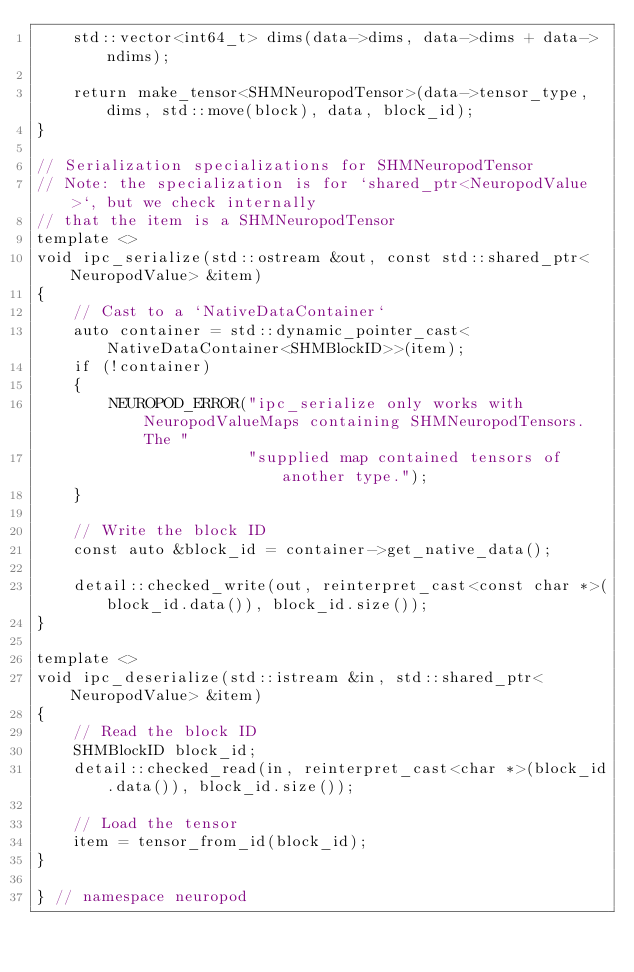Convert code to text. <code><loc_0><loc_0><loc_500><loc_500><_C++_>    std::vector<int64_t> dims(data->dims, data->dims + data->ndims);

    return make_tensor<SHMNeuropodTensor>(data->tensor_type, dims, std::move(block), data, block_id);
}

// Serialization specializations for SHMNeuropodTensor
// Note: the specialization is for `shared_ptr<NeuropodValue>`, but we check internally
// that the item is a SHMNeuropodTensor
template <>
void ipc_serialize(std::ostream &out, const std::shared_ptr<NeuropodValue> &item)
{
    // Cast to a `NativeDataContainer`
    auto container = std::dynamic_pointer_cast<NativeDataContainer<SHMBlockID>>(item);
    if (!container)
    {
        NEUROPOD_ERROR("ipc_serialize only works with NeuropodValueMaps containing SHMNeuropodTensors. The "
                       "supplied map contained tensors of another type.");
    }

    // Write the block ID
    const auto &block_id = container->get_native_data();

    detail::checked_write(out, reinterpret_cast<const char *>(block_id.data()), block_id.size());
}

template <>
void ipc_deserialize(std::istream &in, std::shared_ptr<NeuropodValue> &item)
{
    // Read the block ID
    SHMBlockID block_id;
    detail::checked_read(in, reinterpret_cast<char *>(block_id.data()), block_id.size());

    // Load the tensor
    item = tensor_from_id(block_id);
}

} // namespace neuropod
</code> 